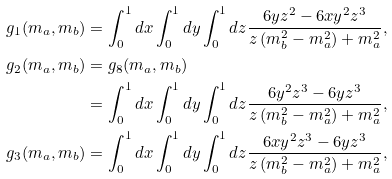<formula> <loc_0><loc_0><loc_500><loc_500>g _ { 1 } ( m _ { a } , m _ { b } ) & = \int ^ { 1 } _ { 0 } d x \int ^ { 1 } _ { 0 } d y \int ^ { 1 } _ { 0 } d z \frac { 6 y z ^ { 2 } - 6 x y ^ { 2 } z ^ { 3 } } { z \left ( m _ { b } ^ { 2 } - m _ { a } ^ { 2 } \right ) + m _ { a } ^ { 2 } } , \\ g _ { 2 } ( m _ { a } , m _ { b } ) & = g _ { 8 } ( m _ { a } , m _ { b } ) \\ & = \int ^ { 1 } _ { 0 } d x \int ^ { 1 } _ { 0 } d y \int ^ { 1 } _ { 0 } d z \frac { 6 y ^ { 2 } z ^ { 3 } - 6 y z ^ { 3 } } { z \left ( m _ { b } ^ { 2 } - m _ { a } ^ { 2 } \right ) + m _ { a } ^ { 2 } } , \\ g _ { 3 } ( m _ { a } , m _ { b } ) & = \int ^ { 1 } _ { 0 } d x \int ^ { 1 } _ { 0 } d y \int ^ { 1 } _ { 0 } d z \frac { 6 x y ^ { 2 } z ^ { 3 } - 6 y z ^ { 3 } } { z \left ( m _ { b } ^ { 2 } - m _ { a } ^ { 2 } \right ) + m _ { a } ^ { 2 } } ,</formula> 